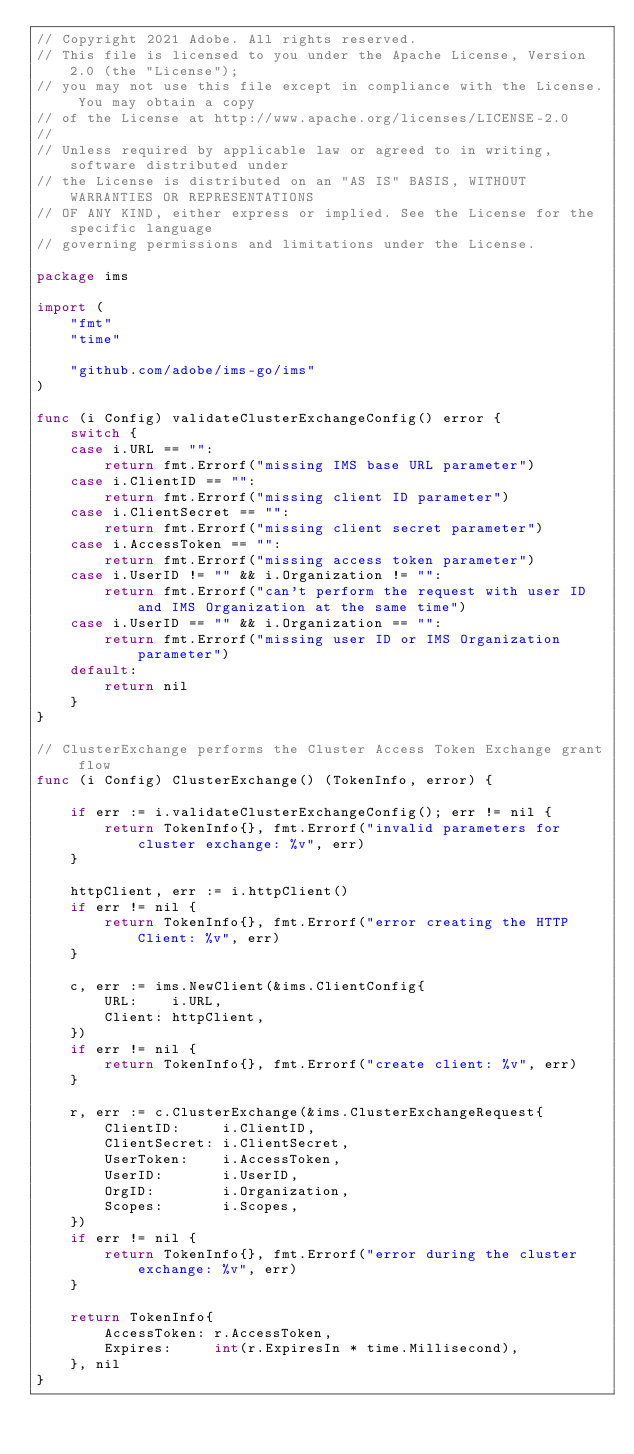Convert code to text. <code><loc_0><loc_0><loc_500><loc_500><_Go_>// Copyright 2021 Adobe. All rights reserved.
// This file is licensed to you under the Apache License, Version 2.0 (the "License");
// you may not use this file except in compliance with the License. You may obtain a copy
// of the License at http://www.apache.org/licenses/LICENSE-2.0
//
// Unless required by applicable law or agreed to in writing, software distributed under
// the License is distributed on an "AS IS" BASIS, WITHOUT WARRANTIES OR REPRESENTATIONS
// OF ANY KIND, either express or implied. See the License for the specific language
// governing permissions and limitations under the License.

package ims

import (
	"fmt"
	"time"

	"github.com/adobe/ims-go/ims"
)

func (i Config) validateClusterExchangeConfig() error {
	switch {
	case i.URL == "":
		return fmt.Errorf("missing IMS base URL parameter")
	case i.ClientID == "":
		return fmt.Errorf("missing client ID parameter")
	case i.ClientSecret == "":
		return fmt.Errorf("missing client secret parameter")
	case i.AccessToken == "":
		return fmt.Errorf("missing access token parameter")
	case i.UserID != "" && i.Organization != "":
		return fmt.Errorf("can't perform the request with user ID and IMS Organization at the same time")
	case i.UserID == "" && i.Organization == "":
		return fmt.Errorf("missing user ID or IMS Organization parameter")
	default:
		return nil
	}
}

// ClusterExchange performs the Cluster Access Token Exchange grant flow
func (i Config) ClusterExchange() (TokenInfo, error) {

	if err := i.validateClusterExchangeConfig(); err != nil {
		return TokenInfo{}, fmt.Errorf("invalid parameters for cluster exchange: %v", err)
	}

	httpClient, err := i.httpClient()
	if err != nil {
		return TokenInfo{}, fmt.Errorf("error creating the HTTP Client: %v", err)
	}

	c, err := ims.NewClient(&ims.ClientConfig{
		URL:    i.URL,
		Client: httpClient,
	})
	if err != nil {
		return TokenInfo{}, fmt.Errorf("create client: %v", err)
	}

	r, err := c.ClusterExchange(&ims.ClusterExchangeRequest{
		ClientID:     i.ClientID,
		ClientSecret: i.ClientSecret,
		UserToken:    i.AccessToken,
		UserID:       i.UserID,
		OrgID:        i.Organization,
		Scopes:       i.Scopes,
	})
	if err != nil {
		return TokenInfo{}, fmt.Errorf("error during the cluster exchange: %v", err)
	}

	return TokenInfo{
		AccessToken: r.AccessToken,
		Expires:     int(r.ExpiresIn * time.Millisecond),
	}, nil
}
</code> 